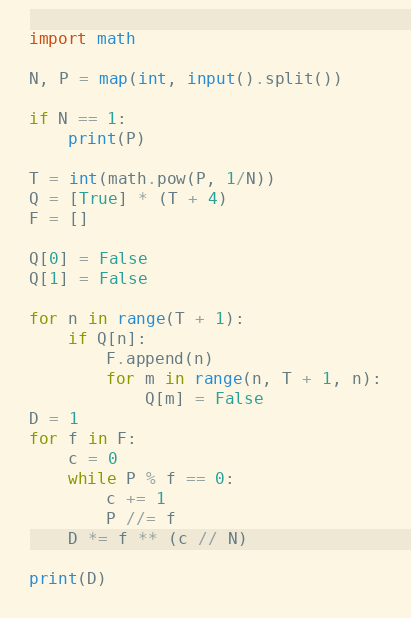Convert code to text. <code><loc_0><loc_0><loc_500><loc_500><_Python_>import math

N, P = map(int, input().split())

if N == 1:
    print(P)

T = int(math.pow(P, 1/N))
Q = [True] * (T + 4)
F = []

Q[0] = False
Q[1] = False

for n in range(T + 1):
    if Q[n]:
        F.append(n)
        for m in range(n, T + 1, n):
            Q[m] = False
D = 1
for f in F:
    c = 0
    while P % f == 0:
        c += 1
        P //= f
    D *= f ** (c // N)

print(D)</code> 